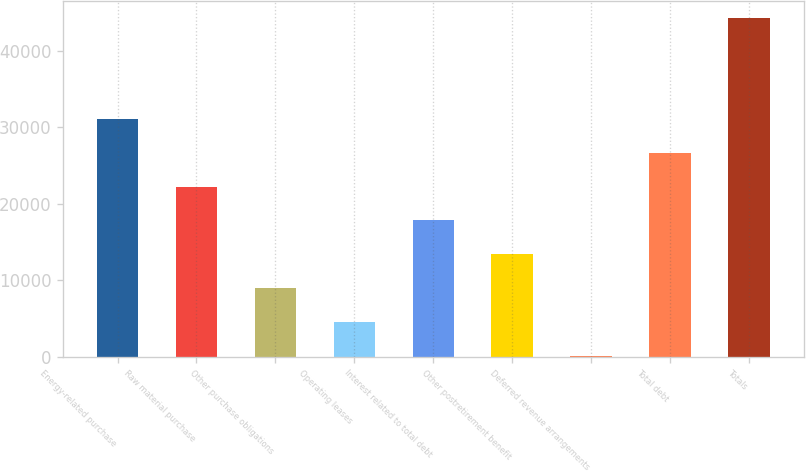Convert chart. <chart><loc_0><loc_0><loc_500><loc_500><bar_chart><fcel>Energy-related purchase<fcel>Raw material purchase<fcel>Other purchase obligations<fcel>Operating leases<fcel>Interest related to total debt<fcel>Other postretirement benefit<fcel>Deferred revenue arrangements<fcel>Total debt<fcel>Totals<nl><fcel>31074.4<fcel>22238<fcel>8983.4<fcel>4565.2<fcel>17819.8<fcel>13401.6<fcel>147<fcel>26656.2<fcel>44329<nl></chart> 